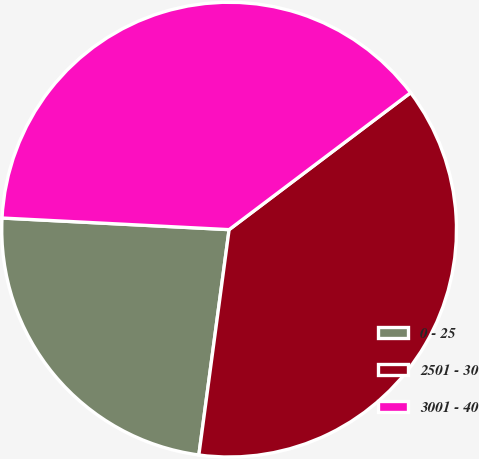Convert chart. <chart><loc_0><loc_0><loc_500><loc_500><pie_chart><fcel>0 - 25<fcel>2501 - 30<fcel>3001 - 40<nl><fcel>23.69%<fcel>37.41%<fcel>38.9%<nl></chart> 